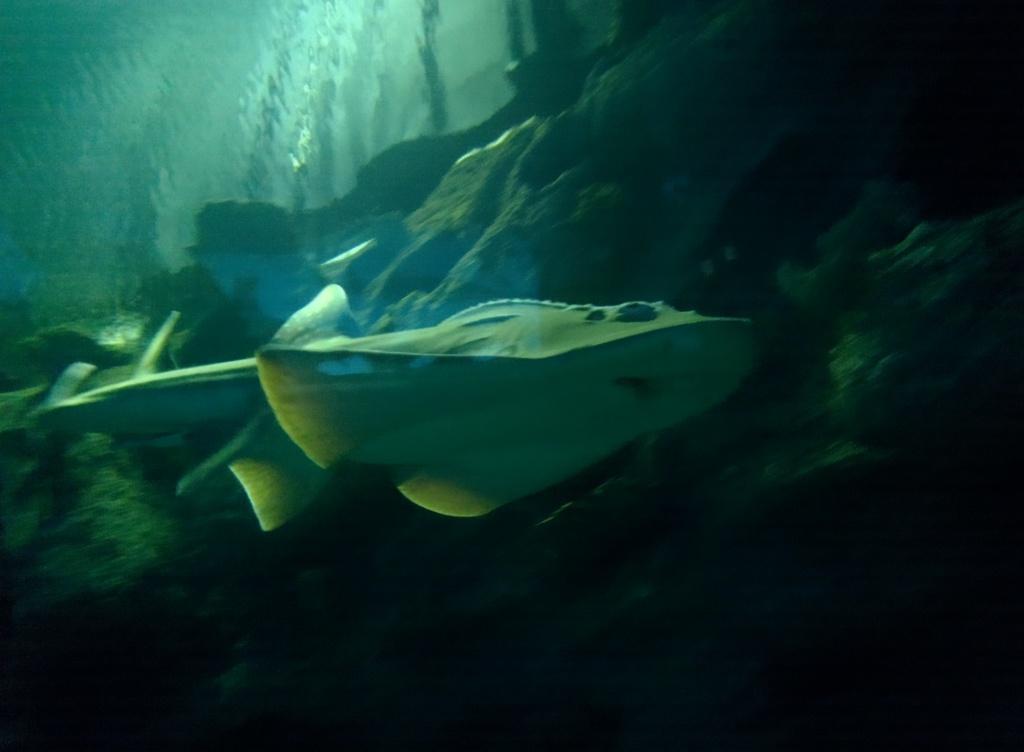How would you summarize this image in a sentence or two? There is a sea animal in the water. In the background, there is hill. 